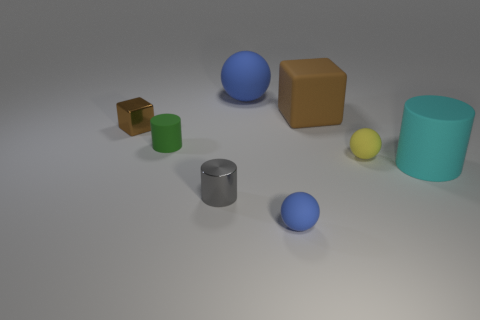Subtract all blue cylinders. Subtract all brown cubes. How many cylinders are left? 3 Subtract all cubes. How many objects are left? 6 Add 6 tiny green rubber things. How many tiny green rubber things exist? 7 Subtract 0 gray blocks. How many objects are left? 8 Subtract all cyan cylinders. Subtract all yellow spheres. How many objects are left? 6 Add 2 small green rubber cylinders. How many small green rubber cylinders are left? 3 